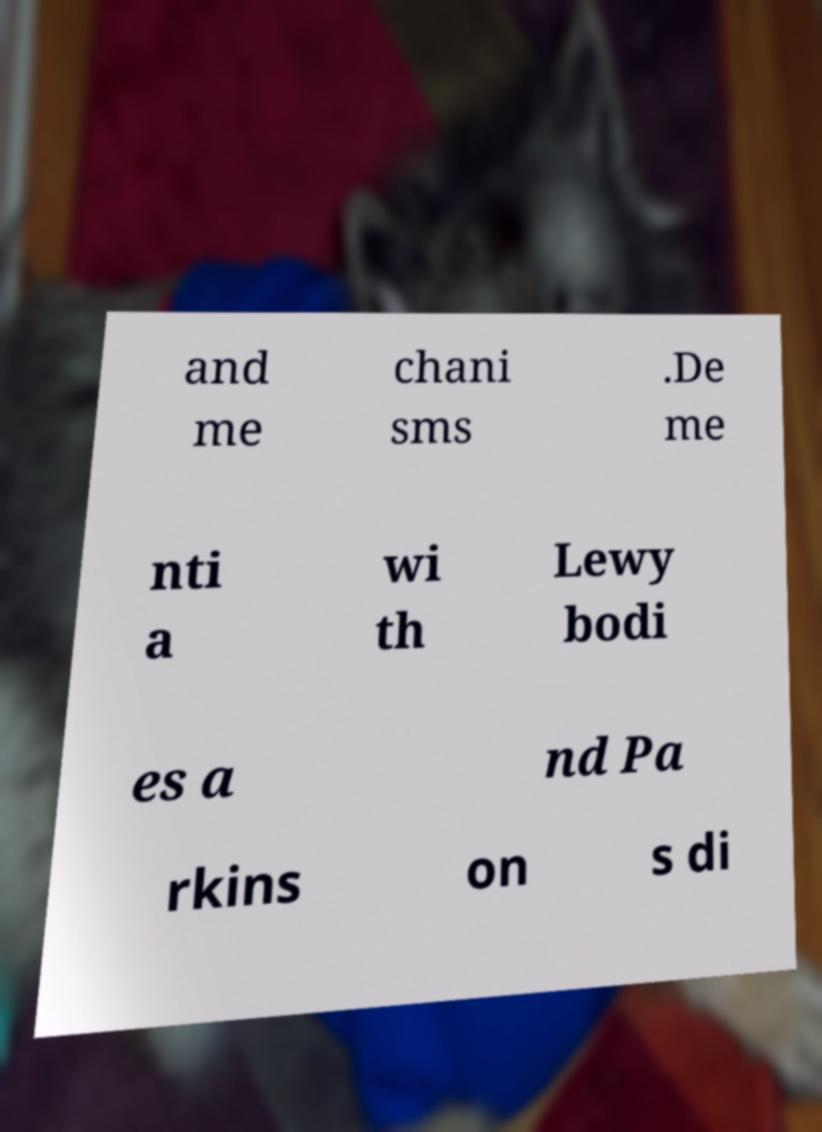Could you assist in decoding the text presented in this image and type it out clearly? and me chani sms .De me nti a wi th Lewy bodi es a nd Pa rkins on s di 